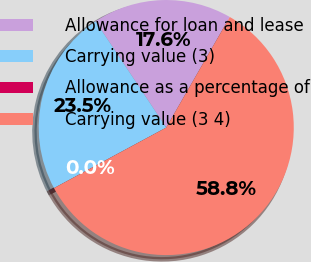Convert chart to OTSL. <chart><loc_0><loc_0><loc_500><loc_500><pie_chart><fcel>Allowance for loan and lease<fcel>Carrying value (3)<fcel>Allowance as a percentage of<fcel>Carrying value (3 4)<nl><fcel>17.65%<fcel>23.53%<fcel>0.0%<fcel>58.82%<nl></chart> 